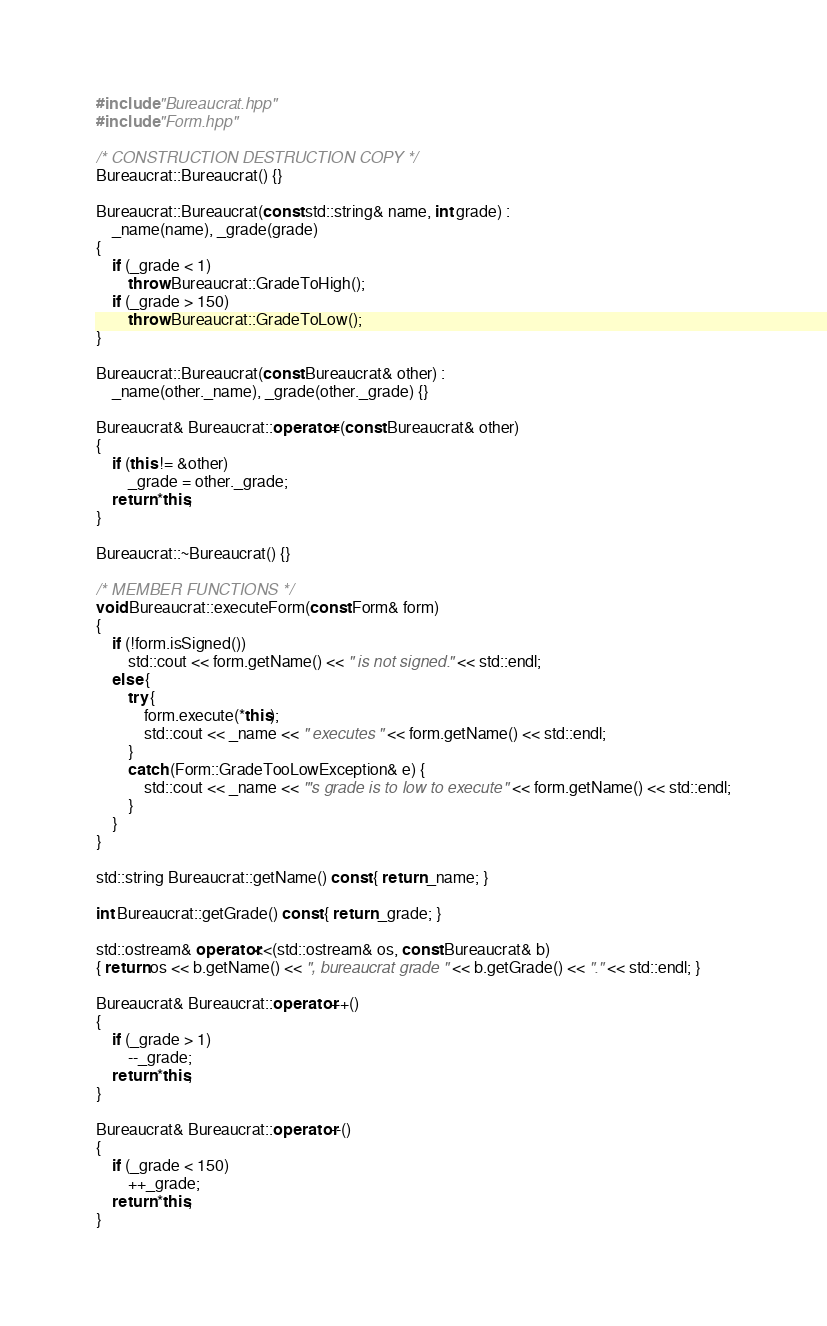<code> <loc_0><loc_0><loc_500><loc_500><_C++_>#include "Bureaucrat.hpp"
#include "Form.hpp"

/* CONSTRUCTION DESTRUCTION COPY */
Bureaucrat::Bureaucrat() {}

Bureaucrat::Bureaucrat(const std::string& name, int grade) :
    _name(name), _grade(grade)
{
    if (_grade < 1)
        throw Bureaucrat::GradeToHigh();
    if (_grade > 150)
        throw Bureaucrat::GradeToLow();
}

Bureaucrat::Bureaucrat(const Bureaucrat& other) :
    _name(other._name), _grade(other._grade) {}

Bureaucrat& Bureaucrat::operator=(const Bureaucrat& other)
{
    if (this != &other)
        _grade = other._grade;
    return *this;
}

Bureaucrat::~Bureaucrat() {}

/* MEMBER FUNCTIONS */
void Bureaucrat::executeForm(const Form& form)
{
    if (!form.isSigned())
        std::cout << form.getName() << " is not signed." << std::endl;
    else {
        try {
            form.execute(*this);
            std::cout << _name << " executes " << form.getName() << std::endl;
        }
        catch (Form::GradeTooLowException& e) {
            std::cout << _name << "'s grade is to low to execute " << form.getName() << std::endl;
        }
    }
}

std::string Bureaucrat::getName() const { return _name; }

int Bureaucrat::getGrade() const { return _grade; }

std::ostream& operator<<(std::ostream& os, const Bureaucrat& b)
{ return os << b.getName() << ", bureaucrat grade " << b.getGrade() << "." << std::endl; }

Bureaucrat& Bureaucrat::operator++()
{
    if (_grade > 1)
        --_grade;
    return *this;
}

Bureaucrat& Bureaucrat::operator--()
{
    if (_grade < 150)
        ++_grade;
    return *this;
}
</code> 